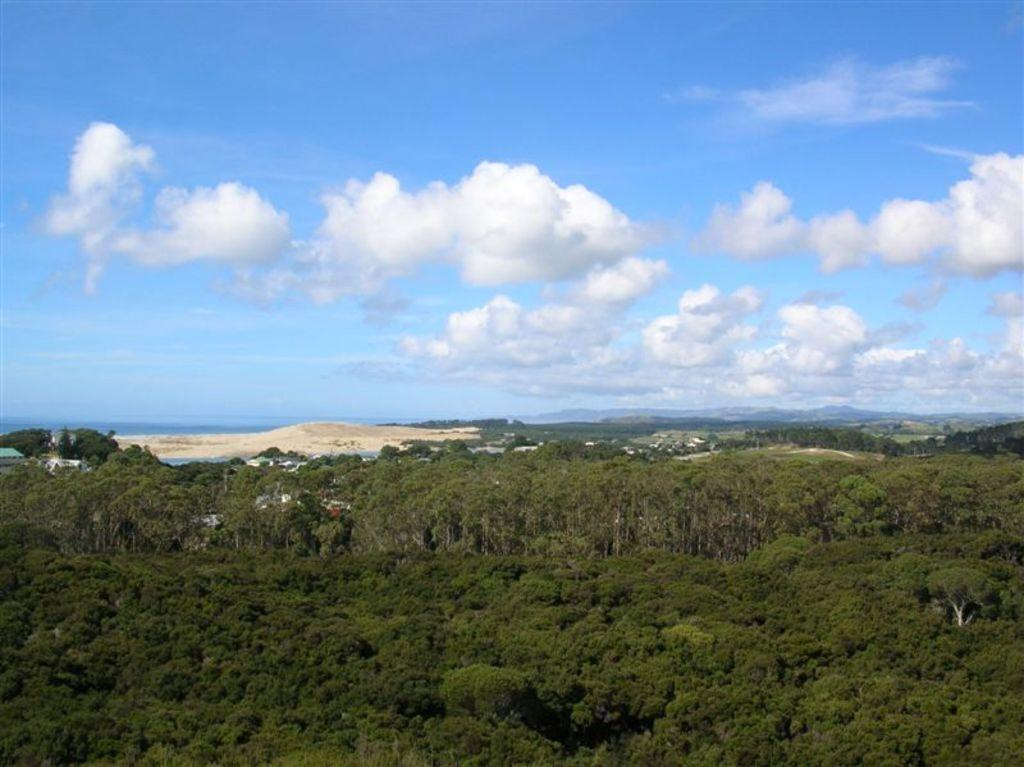What can be seen in the sky in the image? The sky is visible in the image, and there are clouds present. What type of landscape is depicted in the image? The image features hills and trees. What is the texture of the ground in the image? There is a heap of sand in the image, which suggests a sandy texture. What type of pet can be seen participating in the protest in the image? There is no pet or protest present in the image; it features a sky with clouds, hills, trees, and a heap of sand. 